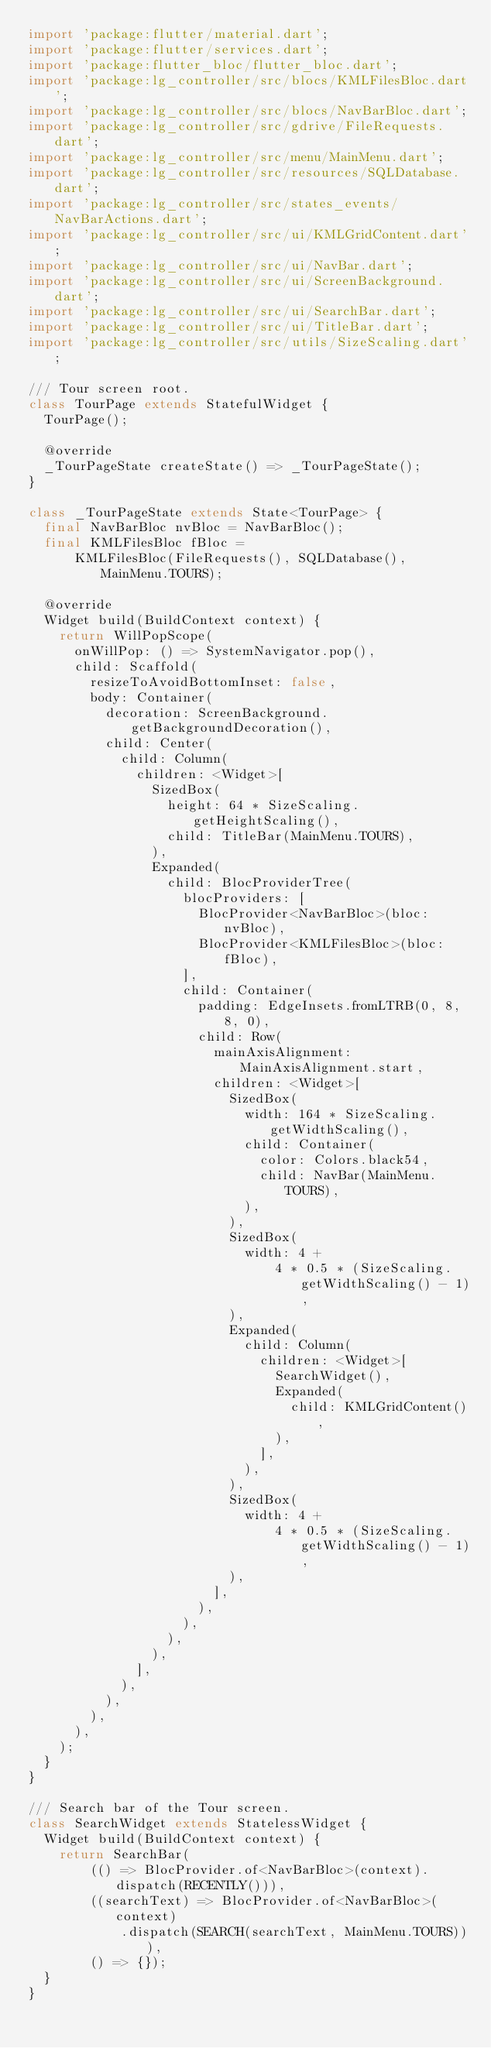<code> <loc_0><loc_0><loc_500><loc_500><_Dart_>import 'package:flutter/material.dart';
import 'package:flutter/services.dart';
import 'package:flutter_bloc/flutter_bloc.dart';
import 'package:lg_controller/src/blocs/KMLFilesBloc.dart';
import 'package:lg_controller/src/blocs/NavBarBloc.dart';
import 'package:lg_controller/src/gdrive/FileRequests.dart';
import 'package:lg_controller/src/menu/MainMenu.dart';
import 'package:lg_controller/src/resources/SQLDatabase.dart';
import 'package:lg_controller/src/states_events/NavBarActions.dart';
import 'package:lg_controller/src/ui/KMLGridContent.dart';
import 'package:lg_controller/src/ui/NavBar.dart';
import 'package:lg_controller/src/ui/ScreenBackground.dart';
import 'package:lg_controller/src/ui/SearchBar.dart';
import 'package:lg_controller/src/ui/TitleBar.dart';
import 'package:lg_controller/src/utils/SizeScaling.dart';

/// Tour screen root.
class TourPage extends StatefulWidget {
  TourPage();

  @override
  _TourPageState createState() => _TourPageState();
}

class _TourPageState extends State<TourPage> {
  final NavBarBloc nvBloc = NavBarBloc();
  final KMLFilesBloc fBloc =
      KMLFilesBloc(FileRequests(), SQLDatabase(), MainMenu.TOURS);

  @override
  Widget build(BuildContext context) {
    return WillPopScope(
      onWillPop: () => SystemNavigator.pop(),
      child: Scaffold(
        resizeToAvoidBottomInset: false,
        body: Container(
          decoration: ScreenBackground.getBackgroundDecoration(),
          child: Center(
            child: Column(
              children: <Widget>[
                SizedBox(
                  height: 64 * SizeScaling.getHeightScaling(),
                  child: TitleBar(MainMenu.TOURS),
                ),
                Expanded(
                  child: BlocProviderTree(
                    blocProviders: [
                      BlocProvider<NavBarBloc>(bloc: nvBloc),
                      BlocProvider<KMLFilesBloc>(bloc: fBloc),
                    ],
                    child: Container(
                      padding: EdgeInsets.fromLTRB(0, 8, 8, 0),
                      child: Row(
                        mainAxisAlignment: MainAxisAlignment.start,
                        children: <Widget>[
                          SizedBox(
                            width: 164 * SizeScaling.getWidthScaling(),
                            child: Container(
                              color: Colors.black54,
                              child: NavBar(MainMenu.TOURS),
                            ),
                          ),
                          SizedBox(
                            width: 4 +
                                4 * 0.5 * (SizeScaling.getWidthScaling() - 1),
                          ),
                          Expanded(
                            child: Column(
                              children: <Widget>[
                                SearchWidget(),
                                Expanded(
                                  child: KMLGridContent(),
                                ),
                              ],
                            ),
                          ),
                          SizedBox(
                            width: 4 +
                                4 * 0.5 * (SizeScaling.getWidthScaling() - 1),
                          ),
                        ],
                      ),
                    ),
                  ),
                ),
              ],
            ),
          ),
        ),
      ),
    );
  }
}

/// Search bar of the Tour screen.
class SearchWidget extends StatelessWidget {
  Widget build(BuildContext context) {
    return SearchBar(
        (() => BlocProvider.of<NavBarBloc>(context).dispatch(RECENTLY())),
        ((searchText) => BlocProvider.of<NavBarBloc>(context)
            .dispatch(SEARCH(searchText, MainMenu.TOURS))),
        () => {});
  }
}
</code> 